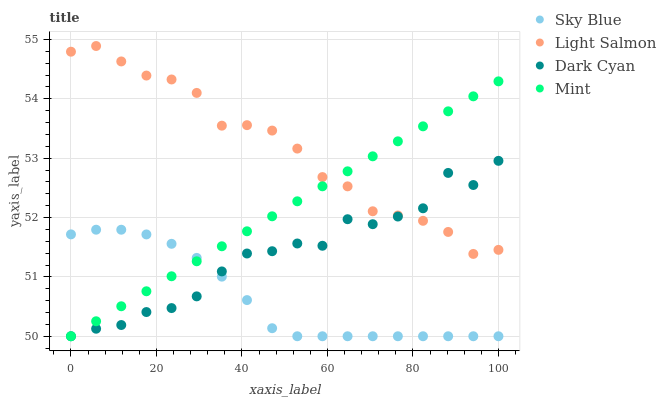Does Sky Blue have the minimum area under the curve?
Answer yes or no. Yes. Does Light Salmon have the maximum area under the curve?
Answer yes or no. Yes. Does Light Salmon have the minimum area under the curve?
Answer yes or no. No. Does Sky Blue have the maximum area under the curve?
Answer yes or no. No. Is Mint the smoothest?
Answer yes or no. Yes. Is Dark Cyan the roughest?
Answer yes or no. Yes. Is Sky Blue the smoothest?
Answer yes or no. No. Is Sky Blue the roughest?
Answer yes or no. No. Does Dark Cyan have the lowest value?
Answer yes or no. Yes. Does Light Salmon have the lowest value?
Answer yes or no. No. Does Light Salmon have the highest value?
Answer yes or no. Yes. Does Sky Blue have the highest value?
Answer yes or no. No. Is Sky Blue less than Light Salmon?
Answer yes or no. Yes. Is Light Salmon greater than Sky Blue?
Answer yes or no. Yes. Does Light Salmon intersect Mint?
Answer yes or no. Yes. Is Light Salmon less than Mint?
Answer yes or no. No. Is Light Salmon greater than Mint?
Answer yes or no. No. Does Sky Blue intersect Light Salmon?
Answer yes or no. No. 